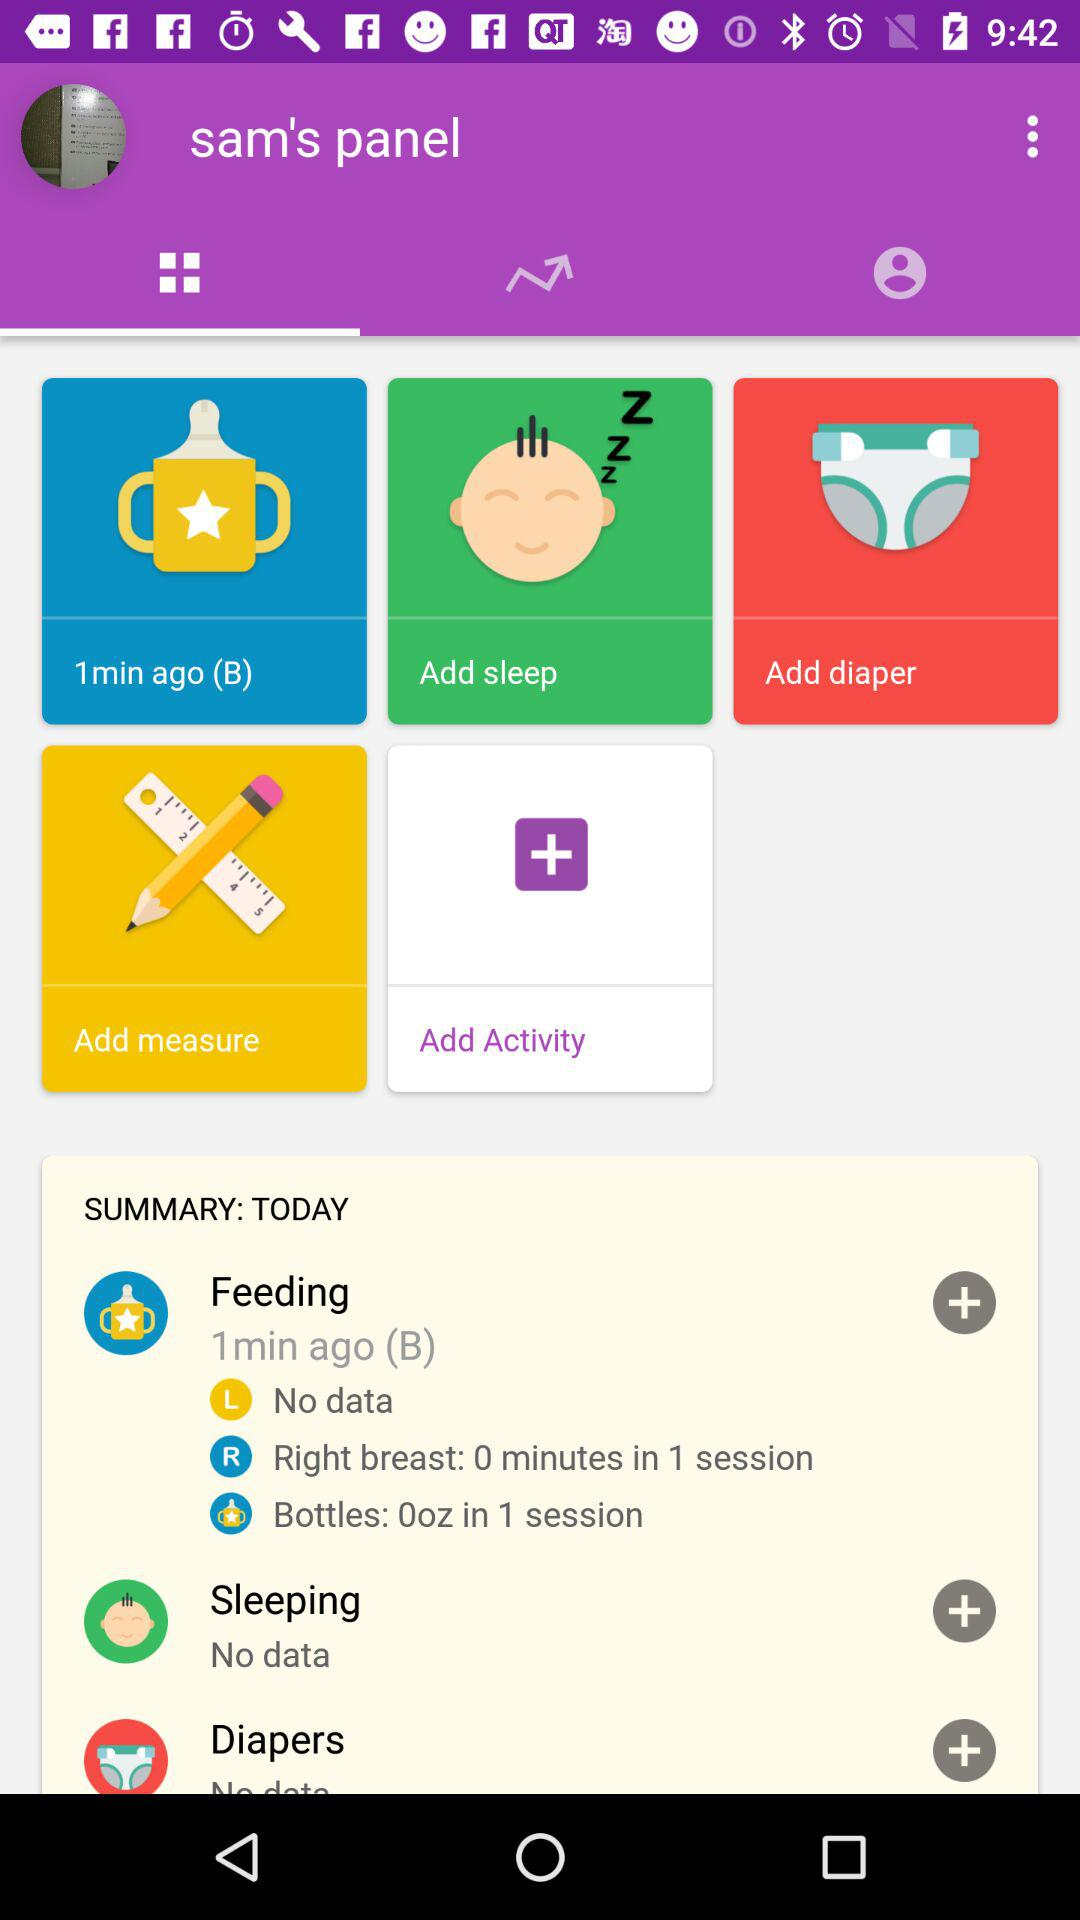What is the data for "Sleeping"? There is no data for "Sleeping". 